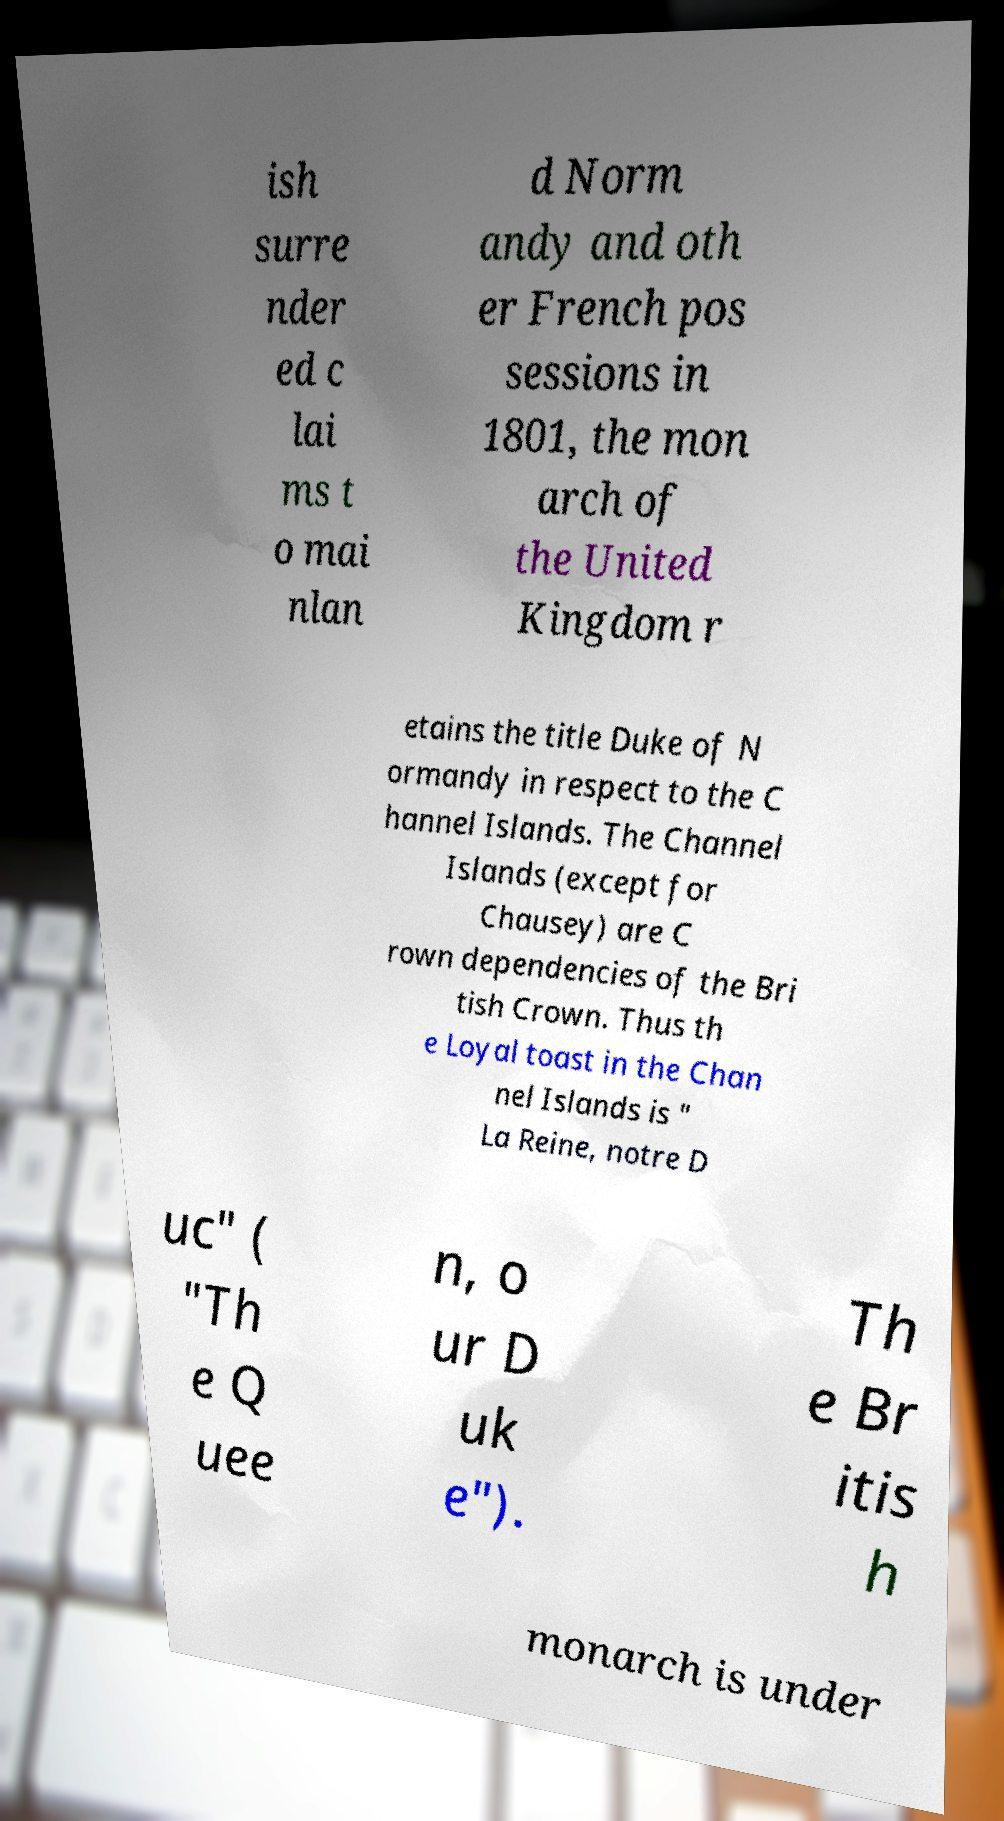Can you accurately transcribe the text from the provided image for me? ish surre nder ed c lai ms t o mai nlan d Norm andy and oth er French pos sessions in 1801, the mon arch of the United Kingdom r etains the title Duke of N ormandy in respect to the C hannel Islands. The Channel Islands (except for Chausey) are C rown dependencies of the Bri tish Crown. Thus th e Loyal toast in the Chan nel Islands is " La Reine, notre D uc" ( "Th e Q uee n, o ur D uk e"). Th e Br itis h monarch is under 